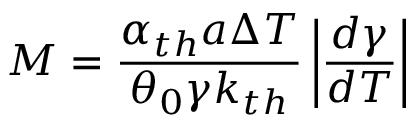<formula> <loc_0><loc_0><loc_500><loc_500>M = \frac { \alpha _ { t h } a \Delta T } { \theta _ { 0 } \gamma k _ { t h } } \left | \frac { d \gamma } { d T } \right |</formula> 